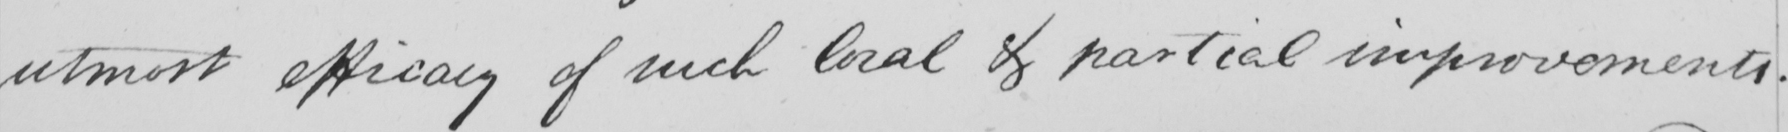What is written in this line of handwriting? utmost efficacy of such local & partial improvements . 